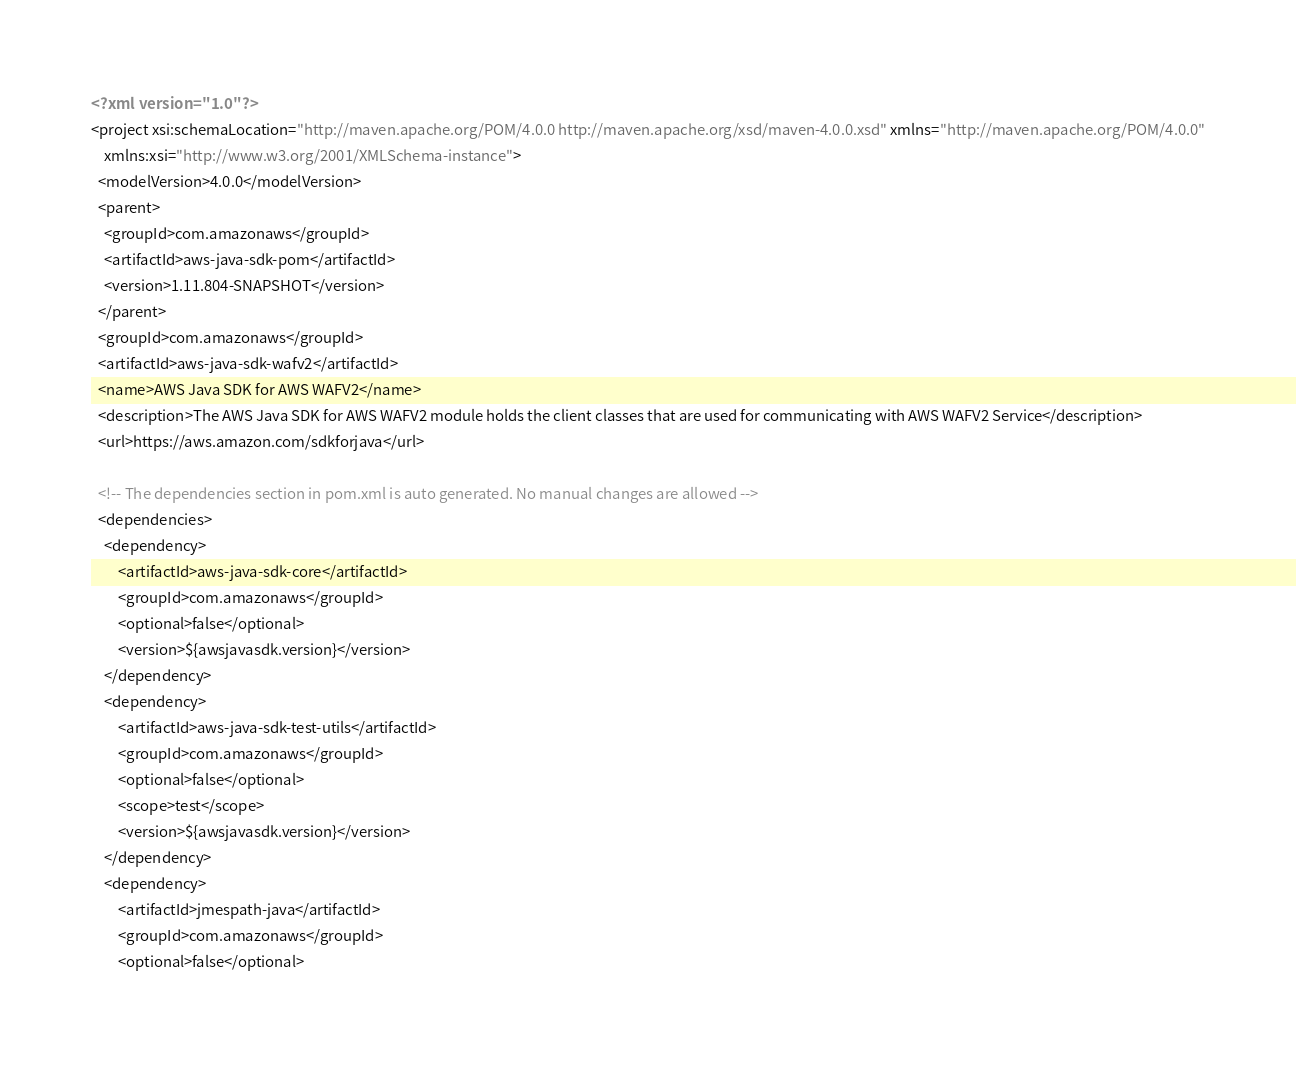<code> <loc_0><loc_0><loc_500><loc_500><_XML_><?xml version="1.0"?>
<project xsi:schemaLocation="http://maven.apache.org/POM/4.0.0 http://maven.apache.org/xsd/maven-4.0.0.xsd" xmlns="http://maven.apache.org/POM/4.0.0"
    xmlns:xsi="http://www.w3.org/2001/XMLSchema-instance">
  <modelVersion>4.0.0</modelVersion>
  <parent>
    <groupId>com.amazonaws</groupId>
    <artifactId>aws-java-sdk-pom</artifactId>
    <version>1.11.804-SNAPSHOT</version>
  </parent>
  <groupId>com.amazonaws</groupId>
  <artifactId>aws-java-sdk-wafv2</artifactId>
  <name>AWS Java SDK for AWS WAFV2</name>
  <description>The AWS Java SDK for AWS WAFV2 module holds the client classes that are used for communicating with AWS WAFV2 Service</description>
  <url>https://aws.amazon.com/sdkforjava</url>

  <!-- The dependencies section in pom.xml is auto generated. No manual changes are allowed -->
  <dependencies>
    <dependency>
        <artifactId>aws-java-sdk-core</artifactId>
        <groupId>com.amazonaws</groupId>
        <optional>false</optional>
        <version>${awsjavasdk.version}</version>
    </dependency>
    <dependency>
        <artifactId>aws-java-sdk-test-utils</artifactId>
        <groupId>com.amazonaws</groupId>
        <optional>false</optional>
        <scope>test</scope>
        <version>${awsjavasdk.version}</version>
    </dependency>
    <dependency>
        <artifactId>jmespath-java</artifactId>
        <groupId>com.amazonaws</groupId>
        <optional>false</optional></code> 